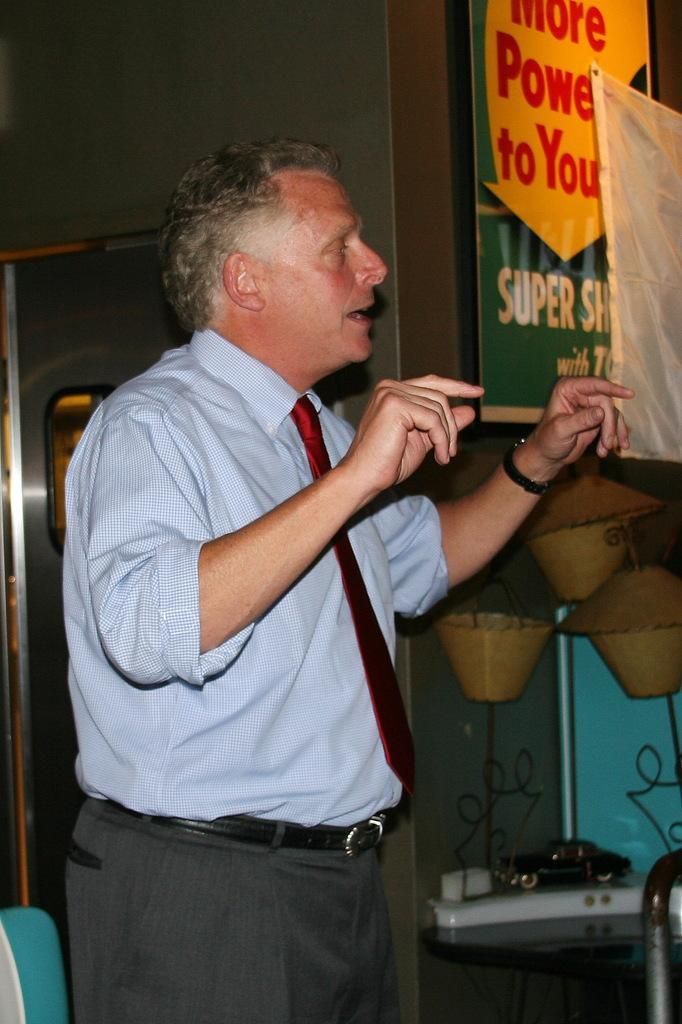<image>
Provide a brief description of the given image. A man in a red tie stands near a sign that reads "more power to you" 